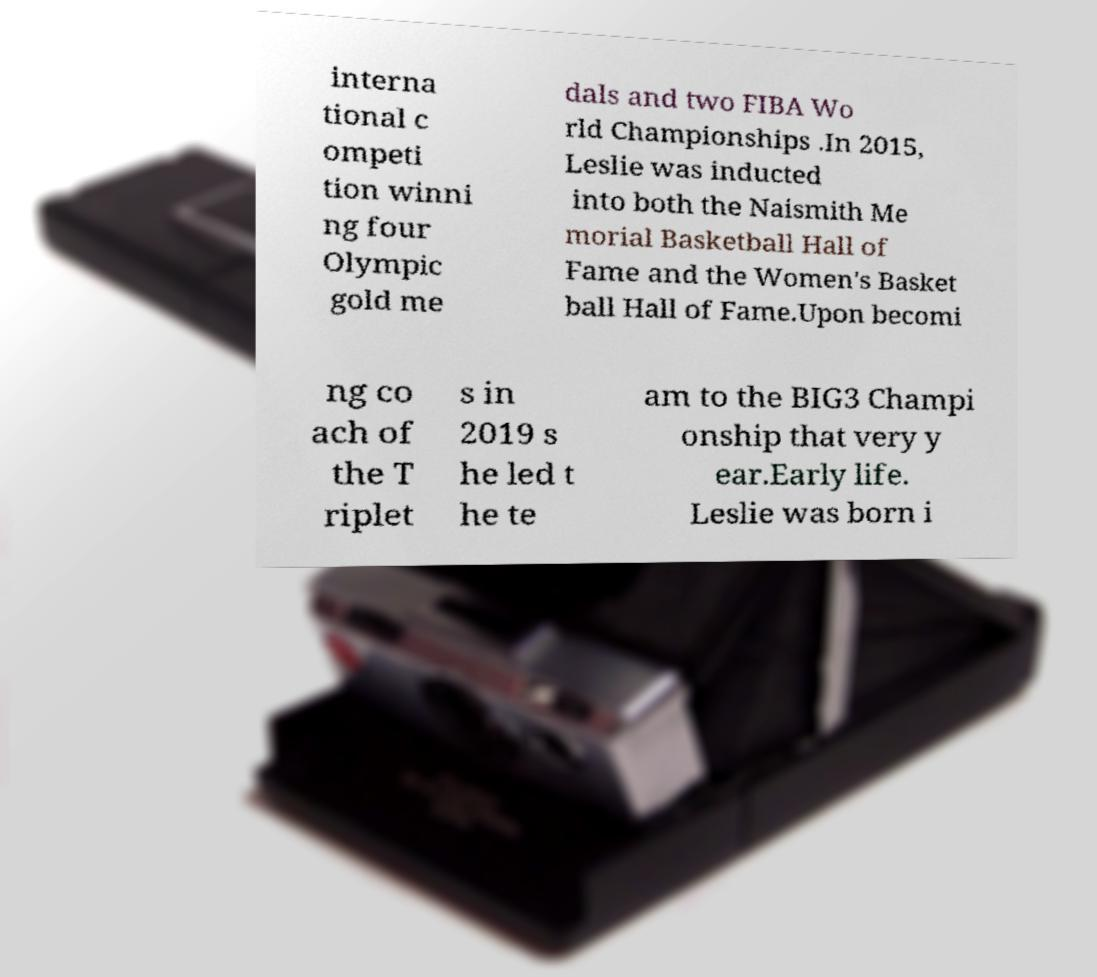Could you assist in decoding the text presented in this image and type it out clearly? interna tional c ompeti tion winni ng four Olympic gold me dals and two FIBA Wo rld Championships .In 2015, Leslie was inducted into both the Naismith Me morial Basketball Hall of Fame and the Women's Basket ball Hall of Fame.Upon becomi ng co ach of the T riplet s in 2019 s he led t he te am to the BIG3 Champi onship that very y ear.Early life. Leslie was born i 